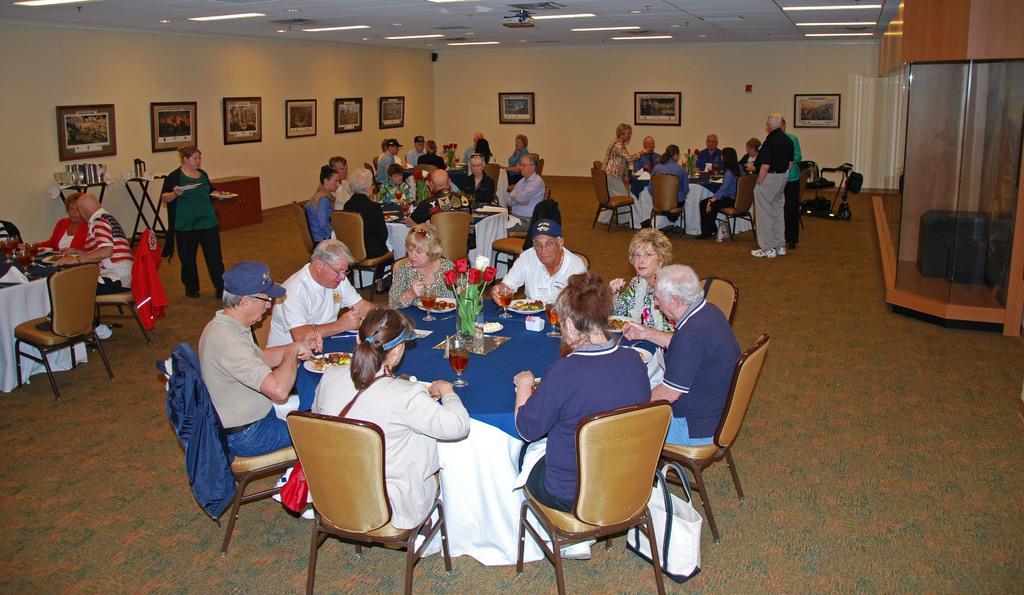Please provide a concise description of this image. In this picture there are group of people sitting on the chair. There is a glass, flower, food in the plate, cloth on table. There is a woman standing and holding two plates in her hand. There are group of people sitting on the chair to the left. There are many frames on the wall. There is a vehicle. There is a glass. There are lights to the roof. 